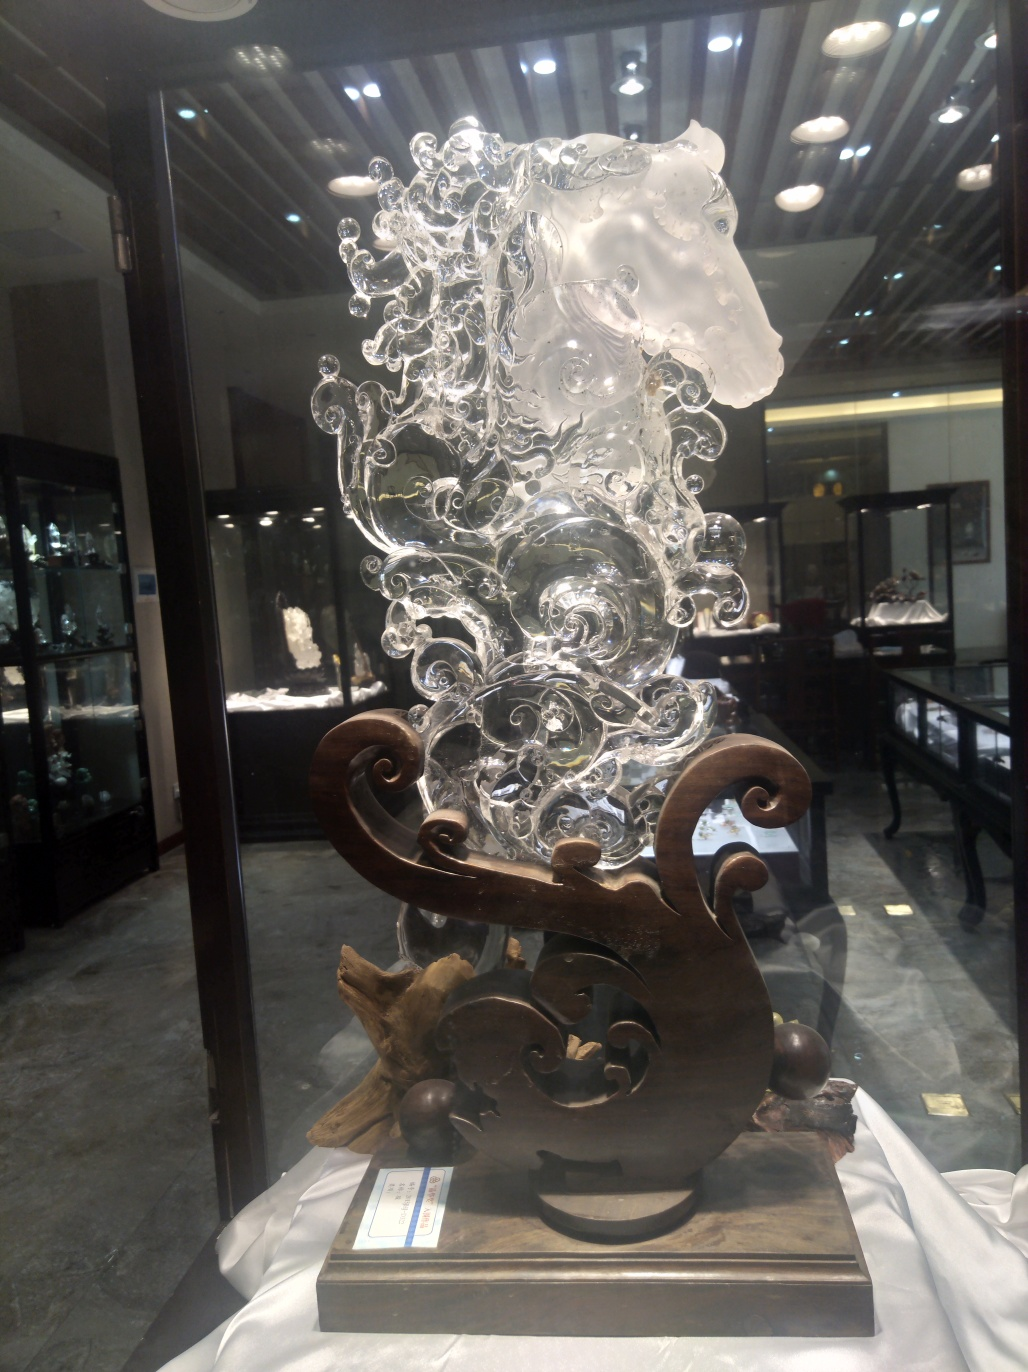How does the medium of glass affect the perception of this artwork? Glass as a medium for this sculpture accentuates its visual and thematic intricacies. The transparency and reflectiveness of glass play with light and shadow, creating a dynamic interaction with the viewer's perspective. This material choice may convey themes of fragility and clarity, metaphorically alluding to broader human experiences or emotions. 